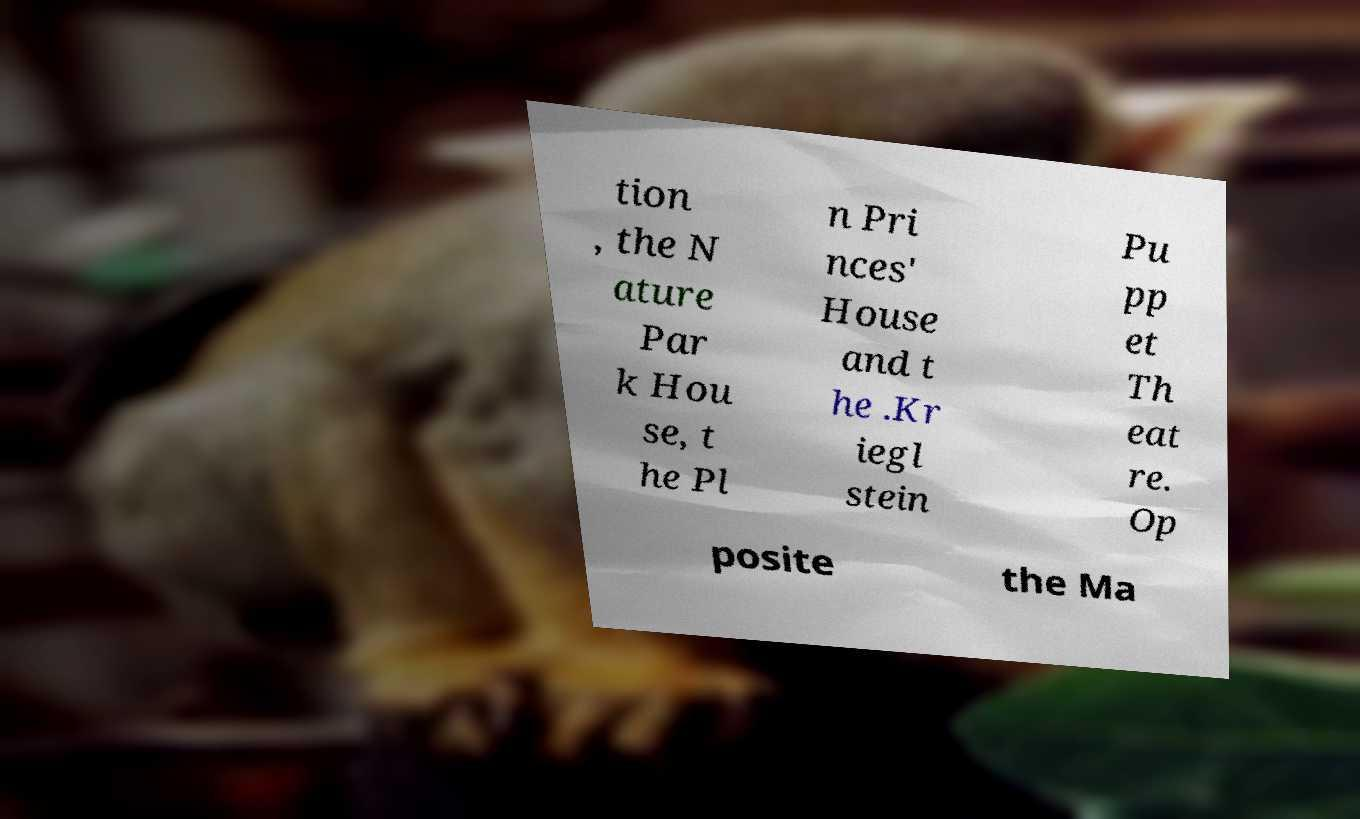Can you accurately transcribe the text from the provided image for me? tion , the N ature Par k Hou se, t he Pl n Pri nces' House and t he .Kr iegl stein Pu pp et Th eat re. Op posite the Ma 